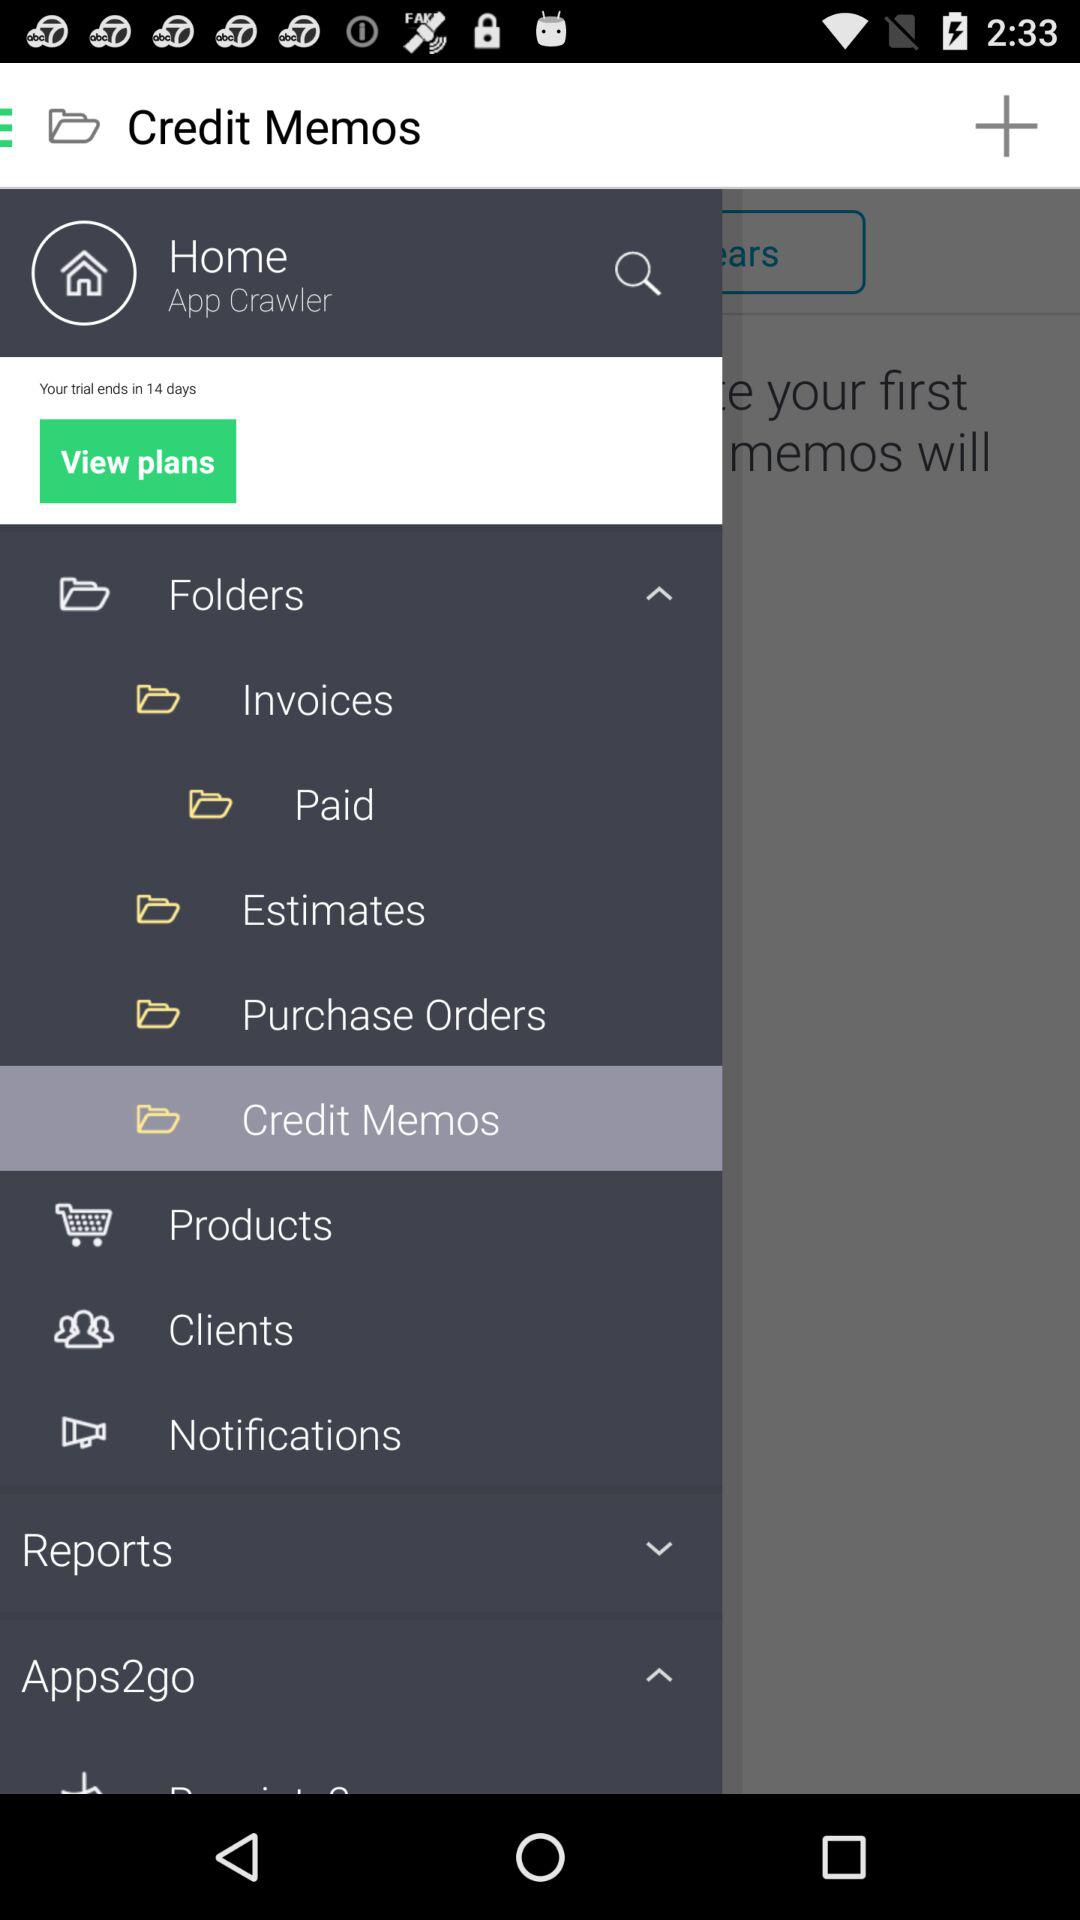How many items are in the cart?
When the provided information is insufficient, respond with <no answer>. <no answer> 